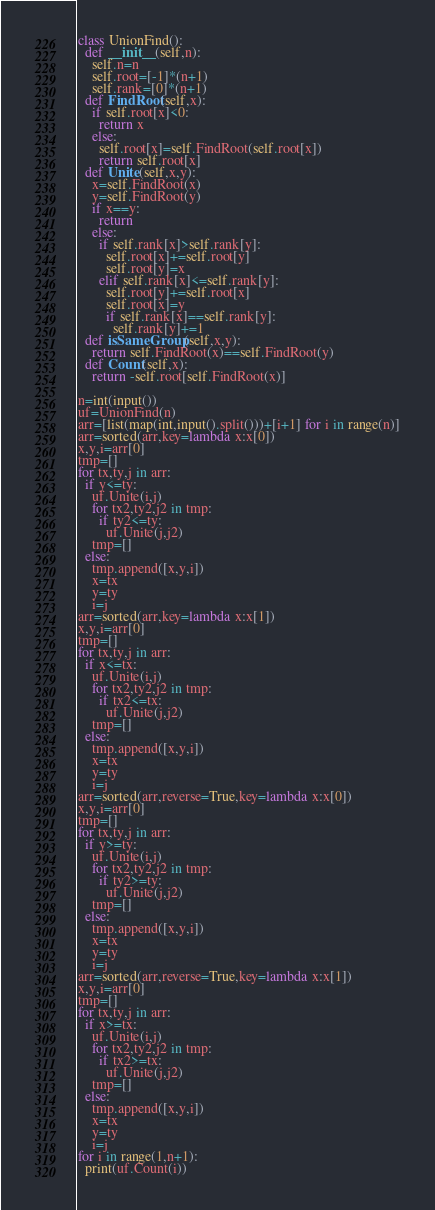<code> <loc_0><loc_0><loc_500><loc_500><_Python_>class UnionFind():
  def __init__(self,n):
    self.n=n
    self.root=[-1]*(n+1)
    self.rank=[0]*(n+1)
  def FindRoot(self,x):
    if self.root[x]<0:
      return x
    else:
      self.root[x]=self.FindRoot(self.root[x])
      return self.root[x]
  def Unite(self,x,y):
    x=self.FindRoot(x)
    y=self.FindRoot(y)
    if x==y:
      return
    else:
      if self.rank[x]>self.rank[y]:
        self.root[x]+=self.root[y]
        self.root[y]=x
      elif self.rank[x]<=self.rank[y]:
        self.root[y]+=self.root[x]
        self.root[x]=y
        if self.rank[x]==self.rank[y]:
          self.rank[y]+=1
  def isSameGroup(self,x,y):
    return self.FindRoot(x)==self.FindRoot(y)
  def Count(self,x):
    return -self.root[self.FindRoot(x)]
  
n=int(input())
uf=UnionFind(n)
arr=[list(map(int,input().split()))+[i+1] for i in range(n)]
arr=sorted(arr,key=lambda x:x[0])
x,y,i=arr[0]
tmp=[]
for tx,ty,j in arr:
  if y<=ty:
    uf.Unite(i,j)
    for tx2,ty2,j2 in tmp:
      if ty2<=ty:
        uf.Unite(j,j2)
    tmp=[]
  else:
    tmp.append([x,y,i])
    x=tx
    y=ty
    i=j
arr=sorted(arr,key=lambda x:x[1])
x,y,i=arr[0]
tmp=[]
for tx,ty,j in arr:
  if x<=tx:
    uf.Unite(i,j)
    for tx2,ty2,j2 in tmp:
      if tx2<=tx:
        uf.Unite(j,j2)
    tmp=[]
  else:
    tmp.append([x,y,i])
    x=tx
    y=ty
    i=j
arr=sorted(arr,reverse=True,key=lambda x:x[0])
x,y,i=arr[0]
tmp=[]
for tx,ty,j in arr:
  if y>=ty:
    uf.Unite(i,j)
    for tx2,ty2,j2 in tmp:
      if ty2>=ty:
        uf.Unite(j,j2)
    tmp=[]
  else:
    tmp.append([x,y,i])
    x=tx
    y=ty
    i=j
arr=sorted(arr,reverse=True,key=lambda x:x[1])
x,y,i=arr[0]
tmp=[]
for tx,ty,j in arr:
  if x>=tx:
    uf.Unite(i,j)
    for tx2,ty2,j2 in tmp:
      if tx2>=tx:
        uf.Unite(j,j2)
    tmp=[]
  else:
    tmp.append([x,y,i])
    x=tx
    y=ty
    i=j
for i in range(1,n+1):
  print(uf.Count(i))</code> 